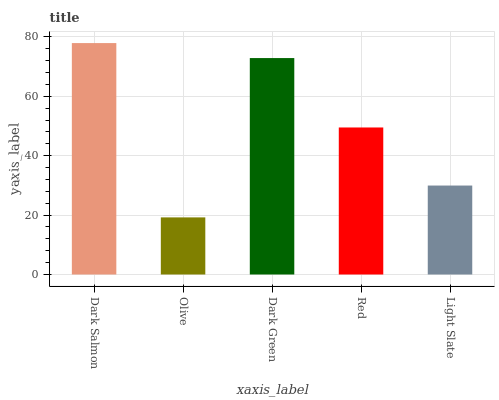Is Dark Green the minimum?
Answer yes or no. No. Is Dark Green the maximum?
Answer yes or no. No. Is Dark Green greater than Olive?
Answer yes or no. Yes. Is Olive less than Dark Green?
Answer yes or no. Yes. Is Olive greater than Dark Green?
Answer yes or no. No. Is Dark Green less than Olive?
Answer yes or no. No. Is Red the high median?
Answer yes or no. Yes. Is Red the low median?
Answer yes or no. Yes. Is Olive the high median?
Answer yes or no. No. Is Olive the low median?
Answer yes or no. No. 